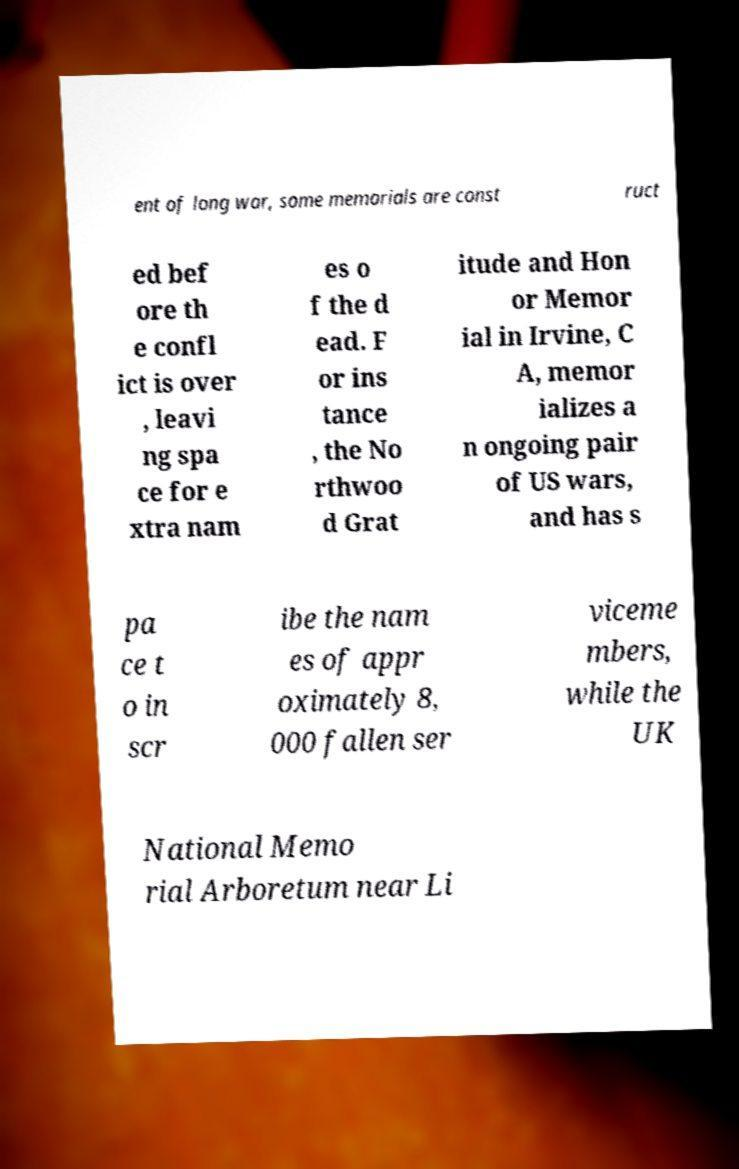What messages or text are displayed in this image? I need them in a readable, typed format. ent of long war, some memorials are const ruct ed bef ore th e confl ict is over , leavi ng spa ce for e xtra nam es o f the d ead. F or ins tance , the No rthwoo d Grat itude and Hon or Memor ial in Irvine, C A, memor ializes a n ongoing pair of US wars, and has s pa ce t o in scr ibe the nam es of appr oximately 8, 000 fallen ser viceme mbers, while the UK National Memo rial Arboretum near Li 